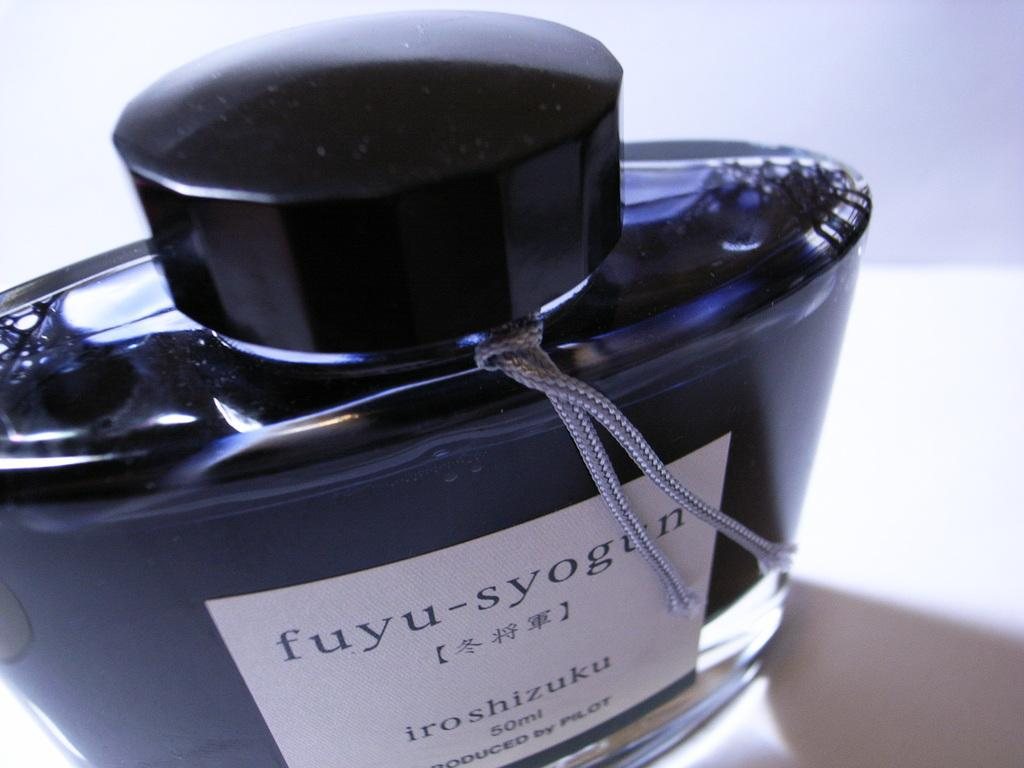<image>
Give a short and clear explanation of the subsequent image. A dark bottle that says fuyu-syogun with a silver string around the neck. 